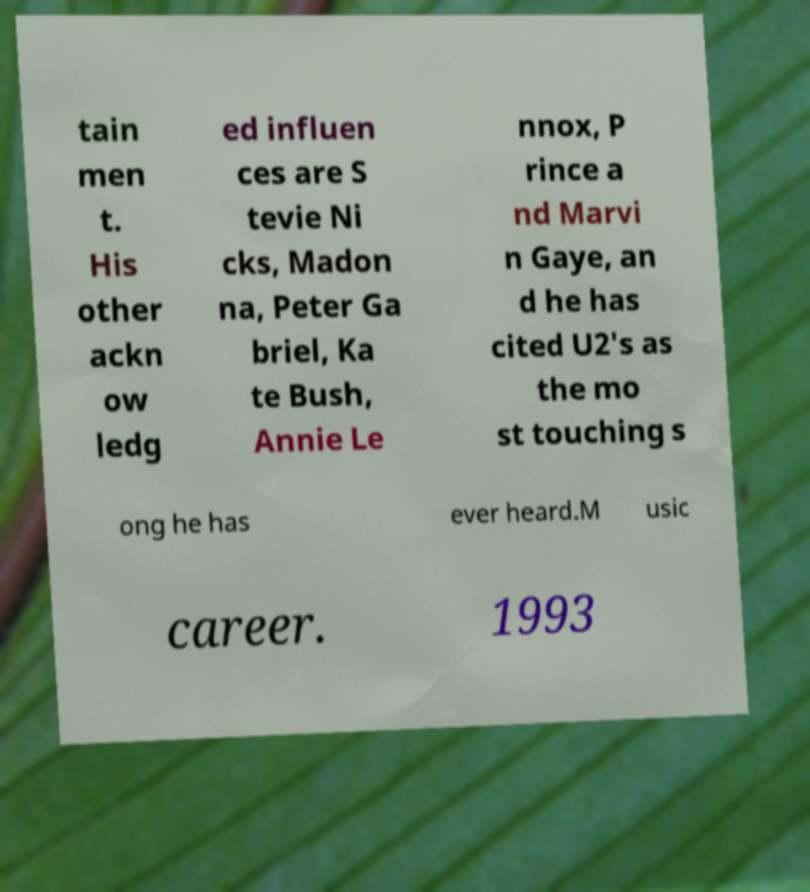Can you read and provide the text displayed in the image?This photo seems to have some interesting text. Can you extract and type it out for me? tain men t. His other ackn ow ledg ed influen ces are S tevie Ni cks, Madon na, Peter Ga briel, Ka te Bush, Annie Le nnox, P rince a nd Marvi n Gaye, an d he has cited U2's as the mo st touching s ong he has ever heard.M usic career. 1993 